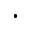Convert formula to latex. <formula><loc_0><loc_0><loc_500><loc_500>\cdot</formula> 